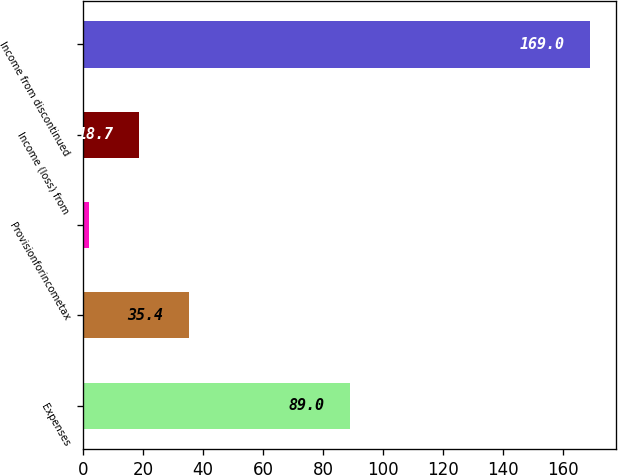<chart> <loc_0><loc_0><loc_500><loc_500><bar_chart><fcel>Expenses<fcel>Unnamed: 1<fcel>Provisionforincometax<fcel>Income (loss) from<fcel>Income from discontinued<nl><fcel>89<fcel>35.4<fcel>2<fcel>18.7<fcel>169<nl></chart> 